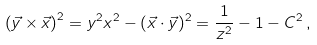<formula> <loc_0><loc_0><loc_500><loc_500>\left ( \vec { y } \times \vec { x } \right ) ^ { 2 } = y ^ { 2 } x ^ { 2 } - ( \vec { x } \cdot \vec { y } ) ^ { 2 } = \frac { 1 } { z ^ { 2 } } - 1 - C ^ { 2 } \, ,</formula> 